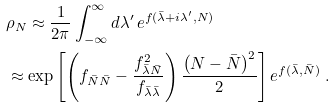Convert formula to latex. <formula><loc_0><loc_0><loc_500><loc_500>& \rho _ { N } \approx \frac { 1 } { 2 \pi } \int _ { - \infty } ^ { \infty } d \lambda ^ { \prime } \, e ^ { f ( \bar { \lambda } + i \lambda ^ { \prime } , N ) } \\ & \approx \exp \left [ \left ( f _ { \bar { N } \bar { N } } - \frac { f _ { \bar { \lambda } \bar { N } } ^ { 2 } } { f _ { \bar { \lambda } \bar { \lambda } } } \right ) \frac { \left ( N - \bar { N } \right ) ^ { 2 } } { 2 } \right ] e ^ { f ( \bar { \lambda } , { \bar { N } } ) } \ .</formula> 